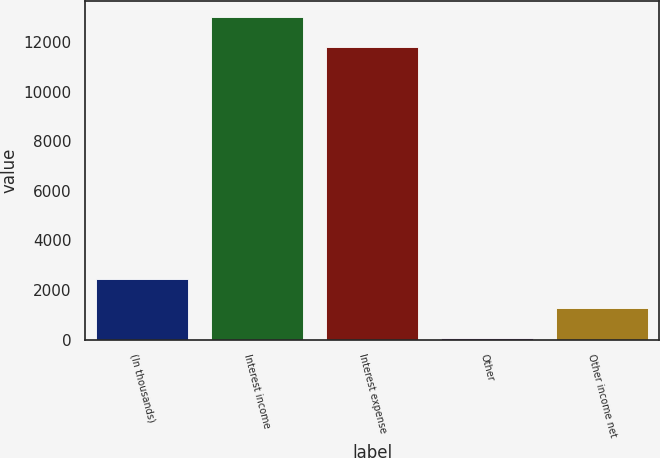<chart> <loc_0><loc_0><loc_500><loc_500><bar_chart><fcel>(In thousands)<fcel>Interest income<fcel>Interest expense<fcel>Other<fcel>Other income net<nl><fcel>2457.2<fcel>13011.6<fcel>11820<fcel>74<fcel>1265.6<nl></chart> 